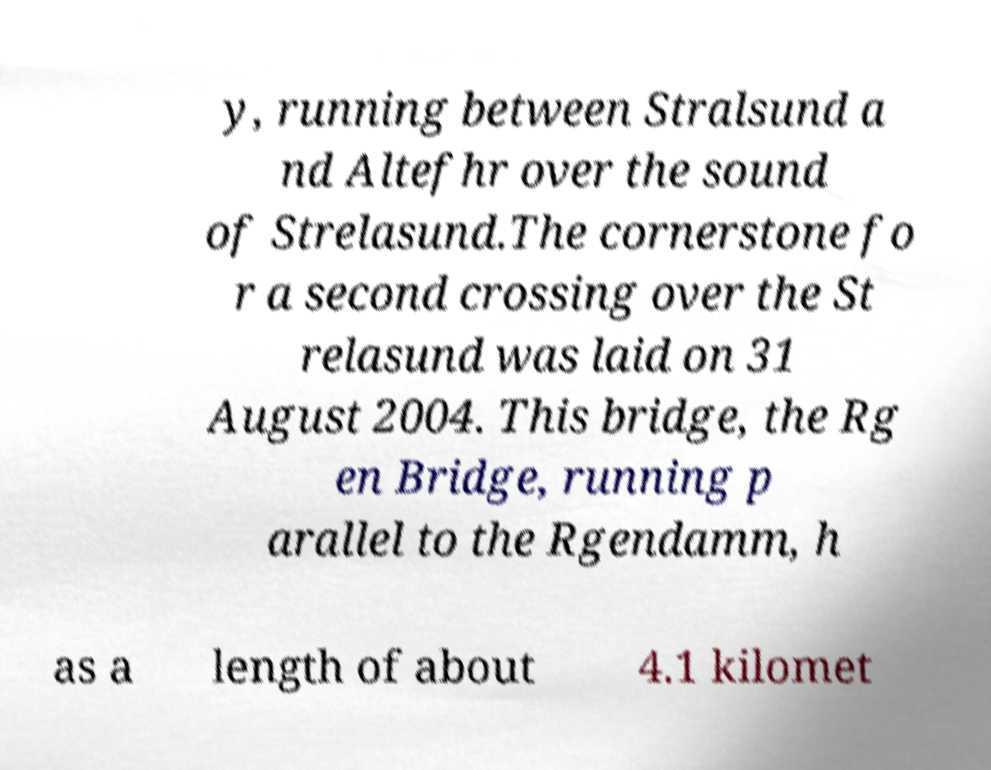Please identify and transcribe the text found in this image. y, running between Stralsund a nd Altefhr over the sound of Strelasund.The cornerstone fo r a second crossing over the St relasund was laid on 31 August 2004. This bridge, the Rg en Bridge, running p arallel to the Rgendamm, h as a length of about 4.1 kilomet 